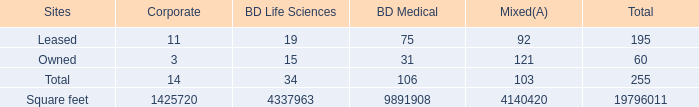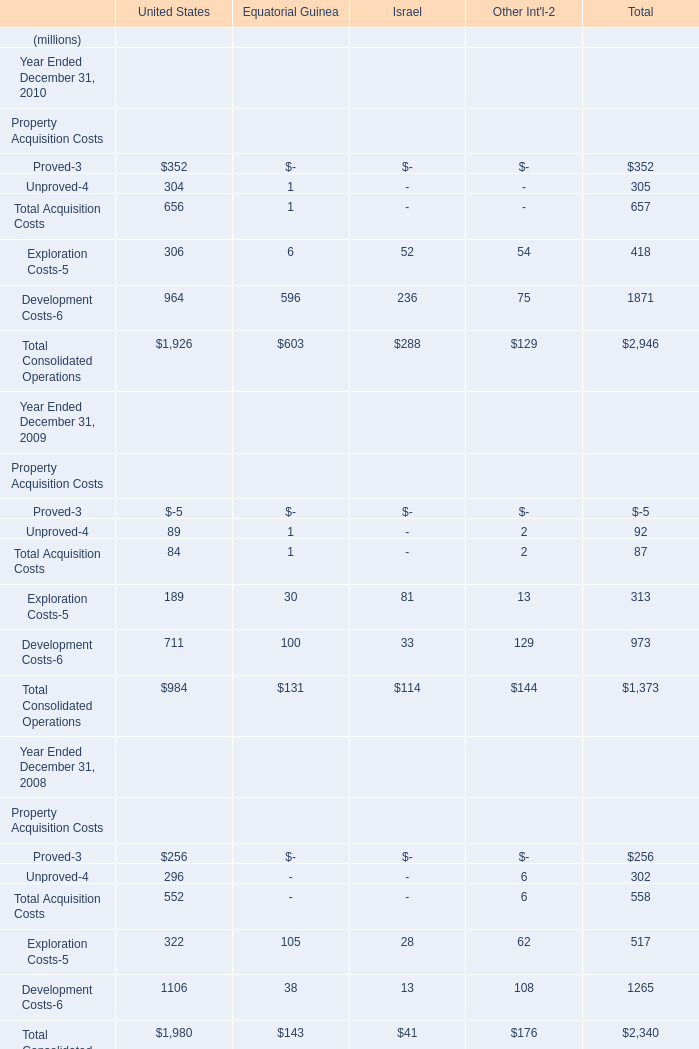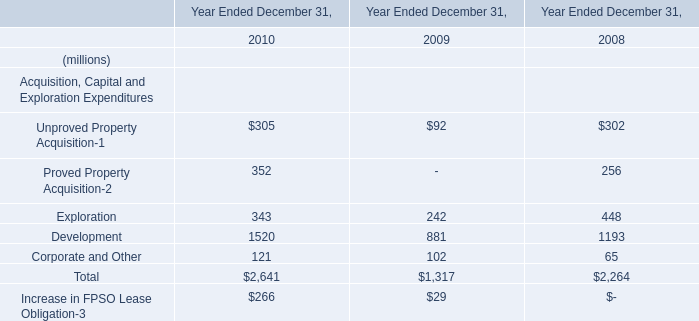as of october 31 , 2016 , what was the average square footage for bd owned or leased facilities? 
Computations: (19796011 / 255)
Answer: 77631.41569. 